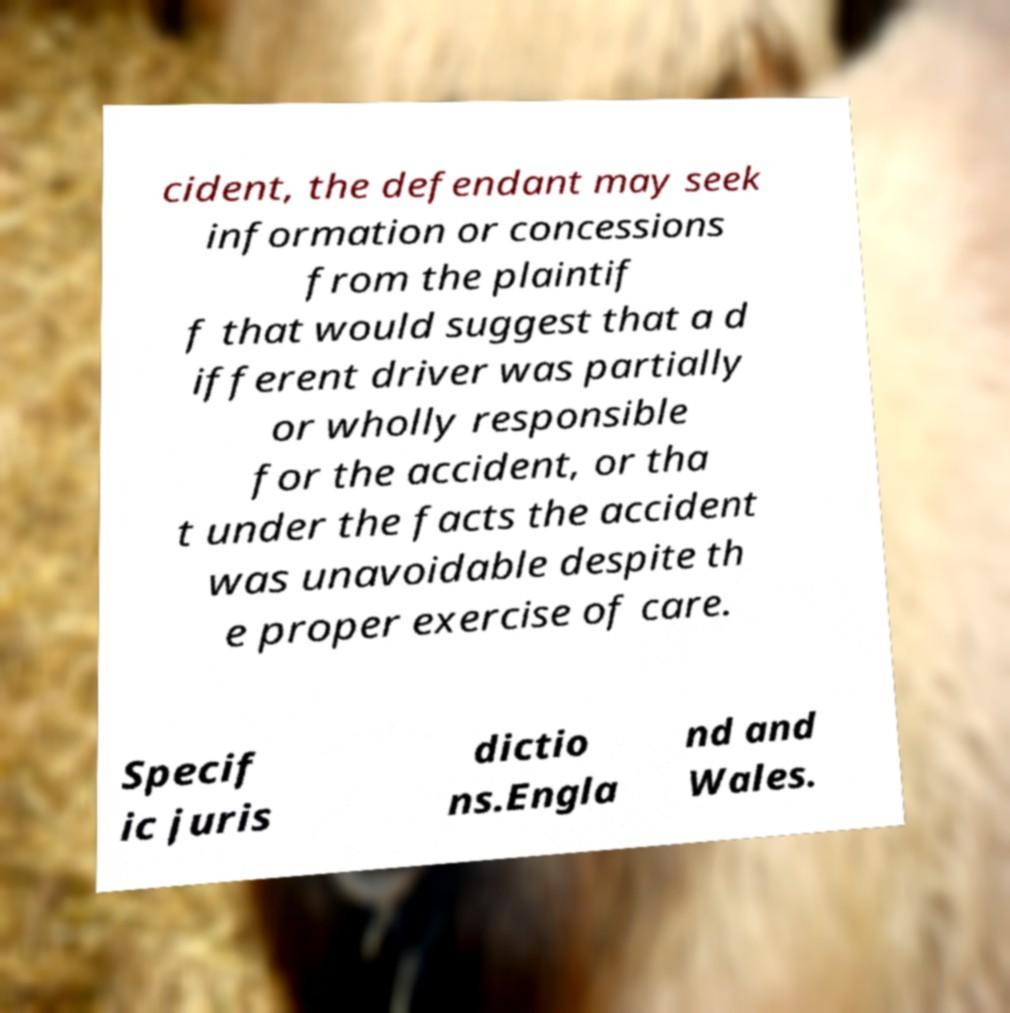Could you assist in decoding the text presented in this image and type it out clearly? cident, the defendant may seek information or concessions from the plaintif f that would suggest that a d ifferent driver was partially or wholly responsible for the accident, or tha t under the facts the accident was unavoidable despite th e proper exercise of care. Specif ic juris dictio ns.Engla nd and Wales. 